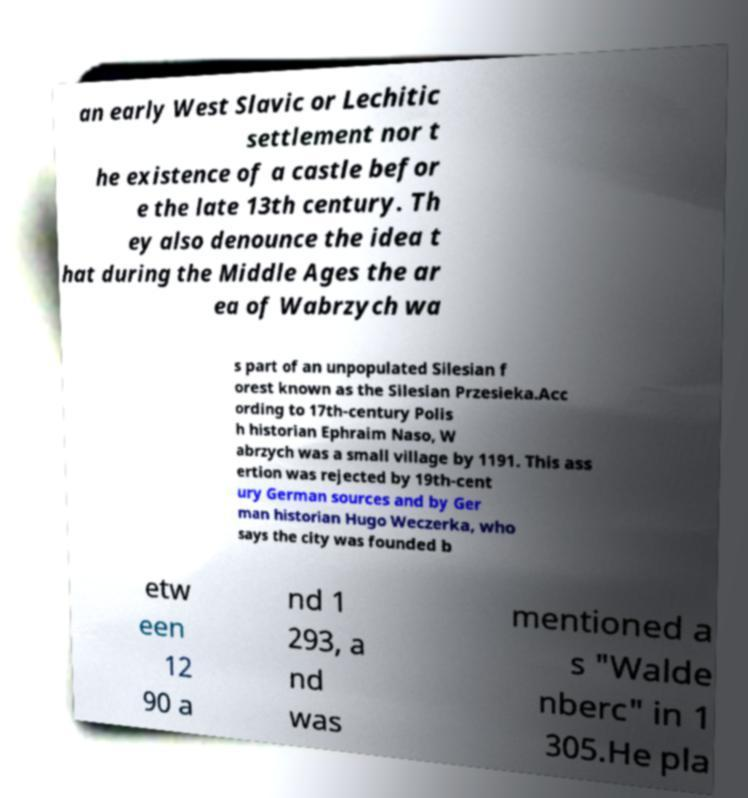Please identify and transcribe the text found in this image. an early West Slavic or Lechitic settlement nor t he existence of a castle befor e the late 13th century. Th ey also denounce the idea t hat during the Middle Ages the ar ea of Wabrzych wa s part of an unpopulated Silesian f orest known as the Silesian Przesieka.Acc ording to 17th-century Polis h historian Ephraim Naso, W abrzych was a small village by 1191. This ass ertion was rejected by 19th-cent ury German sources and by Ger man historian Hugo Weczerka, who says the city was founded b etw een 12 90 a nd 1 293, a nd was mentioned a s "Walde nberc" in 1 305.He pla 